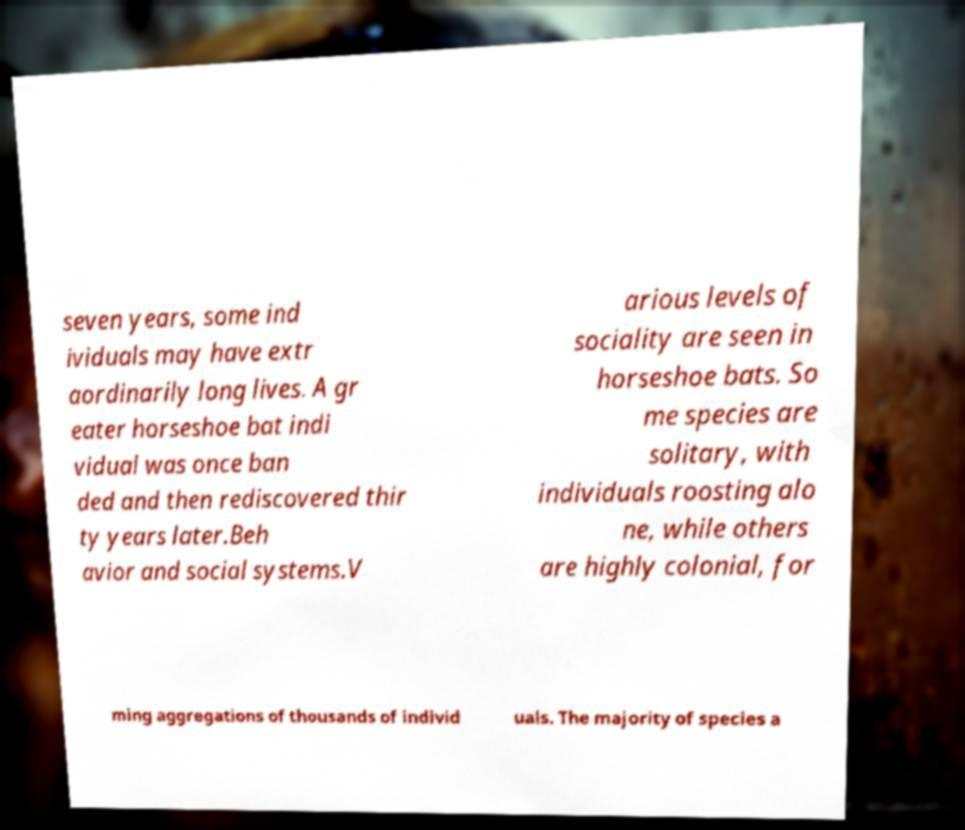I need the written content from this picture converted into text. Can you do that? seven years, some ind ividuals may have extr aordinarily long lives. A gr eater horseshoe bat indi vidual was once ban ded and then rediscovered thir ty years later.Beh avior and social systems.V arious levels of sociality are seen in horseshoe bats. So me species are solitary, with individuals roosting alo ne, while others are highly colonial, for ming aggregations of thousands of individ uals. The majority of species a 